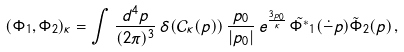Convert formula to latex. <formula><loc_0><loc_0><loc_500><loc_500>( \Phi _ { 1 } , \Phi _ { 2 } ) _ { \kappa } = \int \frac { d ^ { 4 } p } { ( 2 \pi ) ^ { 3 } } \, \delta ( \mathcal { C } _ { \kappa } ( p ) ) \, \frac { p _ { 0 } } { | p _ { 0 } | } \, e ^ { \frac { 3 p _ { 0 } } { \kappa } } \, \tilde { \Phi ^ { * } } _ { 1 } ( \dot { - } p ) \tilde { \Phi } _ { 2 } ( p ) \, ,</formula> 